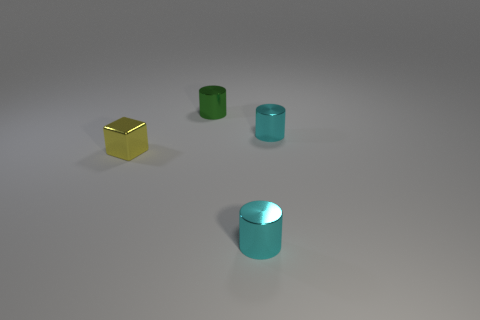Do the metallic object in front of the yellow object and the tiny metal object on the left side of the small green metal thing have the same color?
Keep it short and to the point. No. What is the shape of the green thing?
Keep it short and to the point. Cylinder. Are there more green shiny things that are in front of the block than small cyan objects?
Give a very brief answer. No. There is a small thing on the left side of the tiny green object; what is its shape?
Keep it short and to the point. Cube. How many other things are there of the same shape as the yellow metal object?
Give a very brief answer. 0. Is the material of the cyan cylinder behind the tiny yellow metal block the same as the green thing?
Offer a very short reply. Yes. Are there the same number of tiny cyan metal objects in front of the metal block and yellow objects left of the small green metal thing?
Provide a short and direct response. Yes. There is a shiny cylinder in front of the small metal cube; what is its size?
Offer a terse response. Small. Are there any small yellow things that have the same material as the cube?
Ensure brevity in your answer.  No. Do the object in front of the small yellow metal block and the cube have the same color?
Your answer should be compact. No. 